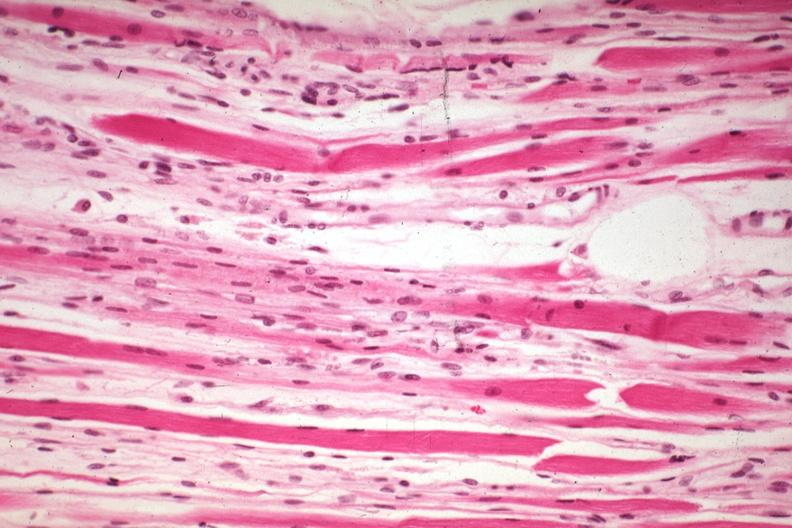what induced atrophy?
Answer the question using a single word or phrase. High excellent steroid 